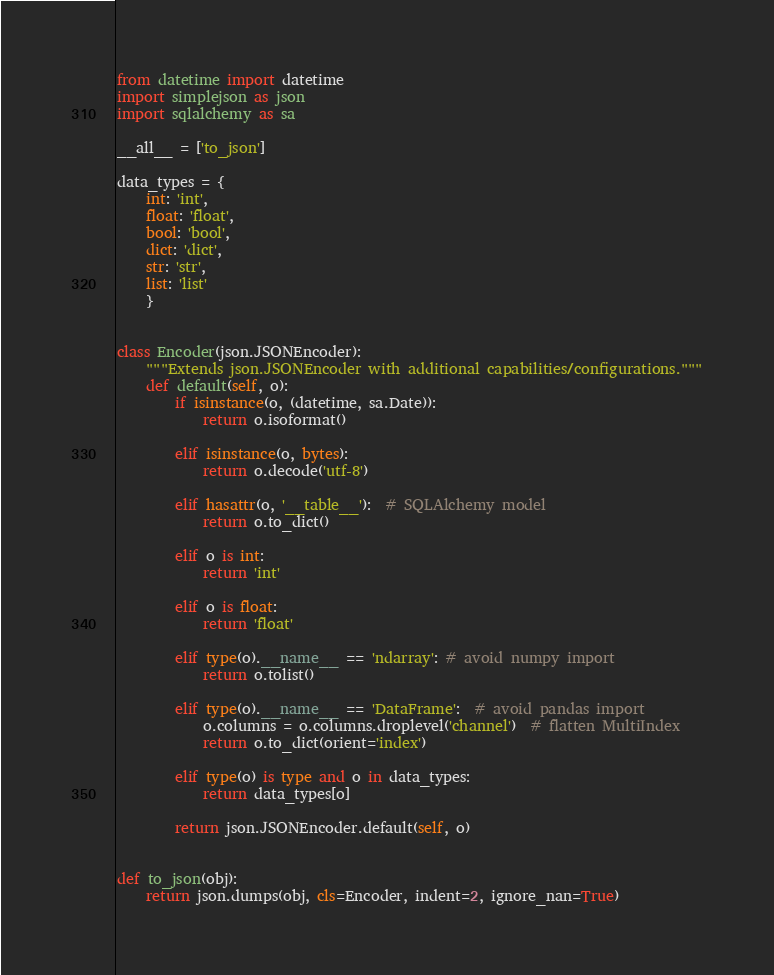<code> <loc_0><loc_0><loc_500><loc_500><_Python_>from datetime import datetime
import simplejson as json
import sqlalchemy as sa

__all__ = ['to_json']

data_types = {
    int: 'int',
    float: 'float',
    bool: 'bool',
    dict: 'dict',
    str: 'str',
    list: 'list'
    }


class Encoder(json.JSONEncoder):
    """Extends json.JSONEncoder with additional capabilities/configurations."""
    def default(self, o):
        if isinstance(o, (datetime, sa.Date)):
            return o.isoformat()

        elif isinstance(o, bytes):
            return o.decode('utf-8')

        elif hasattr(o, '__table__'):  # SQLAlchemy model
            return o.to_dict()

        elif o is int:
            return 'int'

        elif o is float:
            return 'float'

        elif type(o).__name__ == 'ndarray': # avoid numpy import
            return o.tolist()

        elif type(o).__name__ == 'DataFrame':  # avoid pandas import
            o.columns = o.columns.droplevel('channel')  # flatten MultiIndex
            return o.to_dict(orient='index')

        elif type(o) is type and o in data_types:
            return data_types[o]

        return json.JSONEncoder.default(self, o)


def to_json(obj):
    return json.dumps(obj, cls=Encoder, indent=2, ignore_nan=True)
</code> 